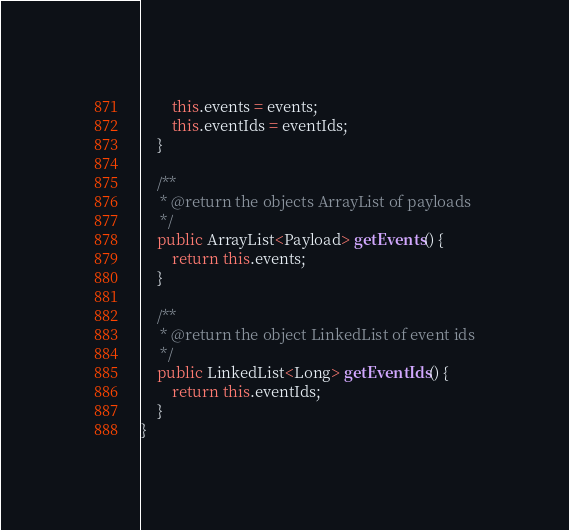Convert code to text. <code><loc_0><loc_0><loc_500><loc_500><_Java_>        this.events = events;
        this.eventIds = eventIds;
    }

    /**
     * @return the objects ArrayList of payloads
     */
    public ArrayList<Payload> getEvents() {
        return this.events;
    }

    /**
     * @return the object LinkedList of event ids
     */
    public LinkedList<Long> getEventIds() {
        return this.eventIds;
    }
}
</code> 